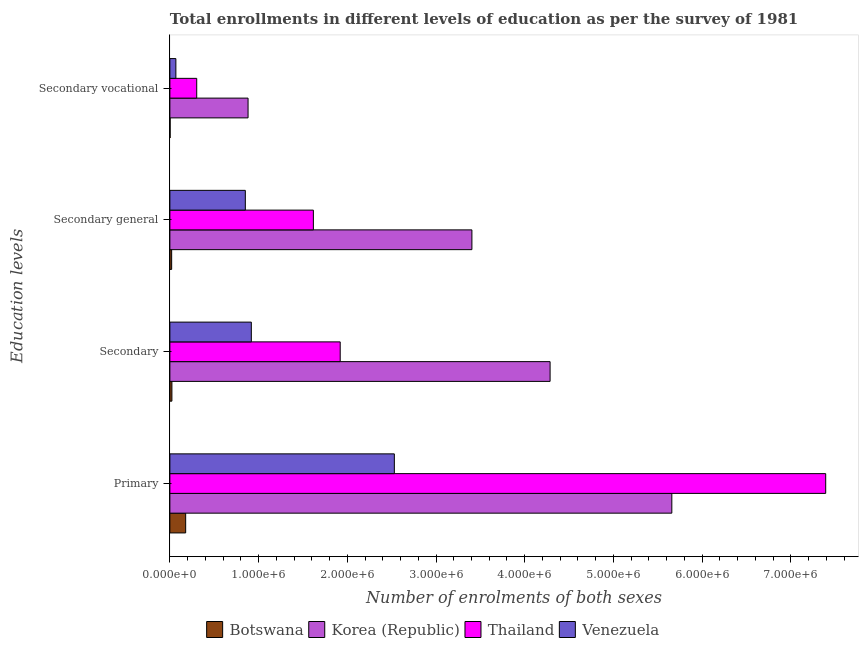How many different coloured bars are there?
Give a very brief answer. 4. Are the number of bars on each tick of the Y-axis equal?
Give a very brief answer. Yes. What is the label of the 3rd group of bars from the top?
Offer a very short reply. Secondary. What is the number of enrolments in primary education in Botswana?
Give a very brief answer. 1.78e+05. Across all countries, what is the maximum number of enrolments in secondary vocational education?
Provide a short and direct response. 8.81e+05. Across all countries, what is the minimum number of enrolments in secondary vocational education?
Ensure brevity in your answer.  2814. In which country was the number of enrolments in primary education maximum?
Provide a succinct answer. Thailand. In which country was the number of enrolments in secondary education minimum?
Provide a short and direct response. Botswana. What is the total number of enrolments in secondary vocational education in the graph?
Your response must be concise. 1.25e+06. What is the difference between the number of enrolments in secondary vocational education in Venezuela and that in Botswana?
Your response must be concise. 6.48e+04. What is the difference between the number of enrolments in secondary education in Korea (Republic) and the number of enrolments in secondary vocational education in Thailand?
Your answer should be compact. 3.98e+06. What is the average number of enrolments in primary education per country?
Give a very brief answer. 3.94e+06. What is the difference between the number of enrolments in secondary general education and number of enrolments in secondary vocational education in Venezuela?
Offer a terse response. 7.83e+05. In how many countries, is the number of enrolments in primary education greater than 4200000 ?
Provide a succinct answer. 2. What is the ratio of the number of enrolments in secondary vocational education in Botswana to that in Thailand?
Offer a very short reply. 0.01. Is the number of enrolments in primary education in Korea (Republic) less than that in Botswana?
Offer a terse response. No. What is the difference between the highest and the second highest number of enrolments in secondary education?
Give a very brief answer. 2.37e+06. What is the difference between the highest and the lowest number of enrolments in primary education?
Your response must be concise. 7.21e+06. In how many countries, is the number of enrolments in secondary education greater than the average number of enrolments in secondary education taken over all countries?
Ensure brevity in your answer.  2. Is it the case that in every country, the sum of the number of enrolments in primary education and number of enrolments in secondary vocational education is greater than the sum of number of enrolments in secondary general education and number of enrolments in secondary education?
Your answer should be compact. No. What does the 1st bar from the top in Primary represents?
Make the answer very short. Venezuela. Is it the case that in every country, the sum of the number of enrolments in primary education and number of enrolments in secondary education is greater than the number of enrolments in secondary general education?
Your answer should be compact. Yes. Are all the bars in the graph horizontal?
Keep it short and to the point. Yes. What is the difference between two consecutive major ticks on the X-axis?
Give a very brief answer. 1.00e+06. Are the values on the major ticks of X-axis written in scientific E-notation?
Your response must be concise. Yes. Does the graph contain any zero values?
Ensure brevity in your answer.  No. Where does the legend appear in the graph?
Make the answer very short. Bottom center. How many legend labels are there?
Provide a succinct answer. 4. What is the title of the graph?
Ensure brevity in your answer.  Total enrollments in different levels of education as per the survey of 1981. Does "Andorra" appear as one of the legend labels in the graph?
Offer a very short reply. No. What is the label or title of the X-axis?
Keep it short and to the point. Number of enrolments of both sexes. What is the label or title of the Y-axis?
Give a very brief answer. Education levels. What is the Number of enrolments of both sexes in Botswana in Primary?
Ensure brevity in your answer.  1.78e+05. What is the Number of enrolments of both sexes of Korea (Republic) in Primary?
Your response must be concise. 5.66e+06. What is the Number of enrolments of both sexes in Thailand in Primary?
Offer a terse response. 7.39e+06. What is the Number of enrolments of both sexes of Venezuela in Primary?
Your answer should be very brief. 2.53e+06. What is the Number of enrolments of both sexes in Botswana in Secondary?
Provide a short and direct response. 2.30e+04. What is the Number of enrolments of both sexes of Korea (Republic) in Secondary?
Offer a terse response. 4.29e+06. What is the Number of enrolments of both sexes in Thailand in Secondary?
Ensure brevity in your answer.  1.92e+06. What is the Number of enrolments of both sexes of Venezuela in Secondary?
Offer a terse response. 9.18e+05. What is the Number of enrolments of both sexes of Botswana in Secondary general?
Provide a succinct answer. 2.01e+04. What is the Number of enrolments of both sexes in Korea (Republic) in Secondary general?
Your answer should be compact. 3.40e+06. What is the Number of enrolments of both sexes of Thailand in Secondary general?
Keep it short and to the point. 1.62e+06. What is the Number of enrolments of both sexes of Venezuela in Secondary general?
Ensure brevity in your answer.  8.50e+05. What is the Number of enrolments of both sexes in Botswana in Secondary vocational?
Keep it short and to the point. 2814. What is the Number of enrolments of both sexes of Korea (Republic) in Secondary vocational?
Your answer should be very brief. 8.81e+05. What is the Number of enrolments of both sexes of Thailand in Secondary vocational?
Offer a terse response. 3.03e+05. What is the Number of enrolments of both sexes in Venezuela in Secondary vocational?
Offer a terse response. 6.76e+04. Across all Education levels, what is the maximum Number of enrolments of both sexes in Botswana?
Give a very brief answer. 1.78e+05. Across all Education levels, what is the maximum Number of enrolments of both sexes of Korea (Republic)?
Offer a very short reply. 5.66e+06. Across all Education levels, what is the maximum Number of enrolments of both sexes of Thailand?
Your answer should be very brief. 7.39e+06. Across all Education levels, what is the maximum Number of enrolments of both sexes of Venezuela?
Your response must be concise. 2.53e+06. Across all Education levels, what is the minimum Number of enrolments of both sexes in Botswana?
Provide a short and direct response. 2814. Across all Education levels, what is the minimum Number of enrolments of both sexes of Korea (Republic)?
Provide a short and direct response. 8.81e+05. Across all Education levels, what is the minimum Number of enrolments of both sexes of Thailand?
Offer a terse response. 3.03e+05. Across all Education levels, what is the minimum Number of enrolments of both sexes of Venezuela?
Provide a short and direct response. 6.76e+04. What is the total Number of enrolments of both sexes of Botswana in the graph?
Ensure brevity in your answer.  2.24e+05. What is the total Number of enrolments of both sexes of Korea (Republic) in the graph?
Keep it short and to the point. 1.42e+07. What is the total Number of enrolments of both sexes in Thailand in the graph?
Your response must be concise. 1.12e+07. What is the total Number of enrolments of both sexes in Venezuela in the graph?
Your answer should be compact. 4.37e+06. What is the difference between the Number of enrolments of both sexes of Botswana in Primary and that in Secondary?
Offer a very short reply. 1.55e+05. What is the difference between the Number of enrolments of both sexes in Korea (Republic) in Primary and that in Secondary?
Your response must be concise. 1.37e+06. What is the difference between the Number of enrolments of both sexes in Thailand in Primary and that in Secondary?
Give a very brief answer. 5.47e+06. What is the difference between the Number of enrolments of both sexes in Venezuela in Primary and that in Secondary?
Keep it short and to the point. 1.61e+06. What is the difference between the Number of enrolments of both sexes in Botswana in Primary and that in Secondary general?
Your response must be concise. 1.58e+05. What is the difference between the Number of enrolments of both sexes in Korea (Republic) in Primary and that in Secondary general?
Your answer should be very brief. 2.25e+06. What is the difference between the Number of enrolments of both sexes in Thailand in Primary and that in Secondary general?
Offer a terse response. 5.78e+06. What is the difference between the Number of enrolments of both sexes of Venezuela in Primary and that in Secondary general?
Keep it short and to the point. 1.68e+06. What is the difference between the Number of enrolments of both sexes in Botswana in Primary and that in Secondary vocational?
Offer a terse response. 1.75e+05. What is the difference between the Number of enrolments of both sexes in Korea (Republic) in Primary and that in Secondary vocational?
Provide a short and direct response. 4.78e+06. What is the difference between the Number of enrolments of both sexes of Thailand in Primary and that in Secondary vocational?
Your response must be concise. 7.09e+06. What is the difference between the Number of enrolments of both sexes in Venezuela in Primary and that in Secondary vocational?
Provide a short and direct response. 2.46e+06. What is the difference between the Number of enrolments of both sexes in Botswana in Secondary and that in Secondary general?
Your answer should be very brief. 2814. What is the difference between the Number of enrolments of both sexes of Korea (Republic) in Secondary and that in Secondary general?
Give a very brief answer. 8.81e+05. What is the difference between the Number of enrolments of both sexes in Thailand in Secondary and that in Secondary general?
Offer a very short reply. 3.03e+05. What is the difference between the Number of enrolments of both sexes in Venezuela in Secondary and that in Secondary general?
Your answer should be compact. 6.76e+04. What is the difference between the Number of enrolments of both sexes of Botswana in Secondary and that in Secondary vocational?
Make the answer very short. 2.01e+04. What is the difference between the Number of enrolments of both sexes of Korea (Republic) in Secondary and that in Secondary vocational?
Offer a terse response. 3.40e+06. What is the difference between the Number of enrolments of both sexes of Thailand in Secondary and that in Secondary vocational?
Give a very brief answer. 1.62e+06. What is the difference between the Number of enrolments of both sexes of Venezuela in Secondary and that in Secondary vocational?
Ensure brevity in your answer.  8.50e+05. What is the difference between the Number of enrolments of both sexes of Botswana in Secondary general and that in Secondary vocational?
Your response must be concise. 1.73e+04. What is the difference between the Number of enrolments of both sexes in Korea (Republic) in Secondary general and that in Secondary vocational?
Keep it short and to the point. 2.52e+06. What is the difference between the Number of enrolments of both sexes in Thailand in Secondary general and that in Secondary vocational?
Provide a succinct answer. 1.31e+06. What is the difference between the Number of enrolments of both sexes of Venezuela in Secondary general and that in Secondary vocational?
Make the answer very short. 7.83e+05. What is the difference between the Number of enrolments of both sexes of Botswana in Primary and the Number of enrolments of both sexes of Korea (Republic) in Secondary?
Your response must be concise. -4.11e+06. What is the difference between the Number of enrolments of both sexes in Botswana in Primary and the Number of enrolments of both sexes in Thailand in Secondary?
Give a very brief answer. -1.74e+06. What is the difference between the Number of enrolments of both sexes in Botswana in Primary and the Number of enrolments of both sexes in Venezuela in Secondary?
Your answer should be very brief. -7.40e+05. What is the difference between the Number of enrolments of both sexes of Korea (Republic) in Primary and the Number of enrolments of both sexes of Thailand in Secondary?
Your answer should be very brief. 3.74e+06. What is the difference between the Number of enrolments of both sexes of Korea (Republic) in Primary and the Number of enrolments of both sexes of Venezuela in Secondary?
Make the answer very short. 4.74e+06. What is the difference between the Number of enrolments of both sexes in Thailand in Primary and the Number of enrolments of both sexes in Venezuela in Secondary?
Your answer should be compact. 6.47e+06. What is the difference between the Number of enrolments of both sexes in Botswana in Primary and the Number of enrolments of both sexes in Korea (Republic) in Secondary general?
Offer a very short reply. -3.23e+06. What is the difference between the Number of enrolments of both sexes of Botswana in Primary and the Number of enrolments of both sexes of Thailand in Secondary general?
Give a very brief answer. -1.44e+06. What is the difference between the Number of enrolments of both sexes in Botswana in Primary and the Number of enrolments of both sexes in Venezuela in Secondary general?
Make the answer very short. -6.72e+05. What is the difference between the Number of enrolments of both sexes of Korea (Republic) in Primary and the Number of enrolments of both sexes of Thailand in Secondary general?
Keep it short and to the point. 4.04e+06. What is the difference between the Number of enrolments of both sexes in Korea (Republic) in Primary and the Number of enrolments of both sexes in Venezuela in Secondary general?
Your answer should be very brief. 4.81e+06. What is the difference between the Number of enrolments of both sexes in Thailand in Primary and the Number of enrolments of both sexes in Venezuela in Secondary general?
Keep it short and to the point. 6.54e+06. What is the difference between the Number of enrolments of both sexes of Botswana in Primary and the Number of enrolments of both sexes of Korea (Republic) in Secondary vocational?
Provide a short and direct response. -7.03e+05. What is the difference between the Number of enrolments of both sexes of Botswana in Primary and the Number of enrolments of both sexes of Thailand in Secondary vocational?
Make the answer very short. -1.24e+05. What is the difference between the Number of enrolments of both sexes in Botswana in Primary and the Number of enrolments of both sexes in Venezuela in Secondary vocational?
Provide a short and direct response. 1.10e+05. What is the difference between the Number of enrolments of both sexes of Korea (Republic) in Primary and the Number of enrolments of both sexes of Thailand in Secondary vocational?
Provide a succinct answer. 5.36e+06. What is the difference between the Number of enrolments of both sexes of Korea (Republic) in Primary and the Number of enrolments of both sexes of Venezuela in Secondary vocational?
Offer a terse response. 5.59e+06. What is the difference between the Number of enrolments of both sexes of Thailand in Primary and the Number of enrolments of both sexes of Venezuela in Secondary vocational?
Provide a succinct answer. 7.32e+06. What is the difference between the Number of enrolments of both sexes in Botswana in Secondary and the Number of enrolments of both sexes in Korea (Republic) in Secondary general?
Keep it short and to the point. -3.38e+06. What is the difference between the Number of enrolments of both sexes in Botswana in Secondary and the Number of enrolments of both sexes in Thailand in Secondary general?
Provide a short and direct response. -1.59e+06. What is the difference between the Number of enrolments of both sexes in Botswana in Secondary and the Number of enrolments of both sexes in Venezuela in Secondary general?
Your answer should be compact. -8.28e+05. What is the difference between the Number of enrolments of both sexes of Korea (Republic) in Secondary and the Number of enrolments of both sexes of Thailand in Secondary general?
Offer a terse response. 2.67e+06. What is the difference between the Number of enrolments of both sexes of Korea (Republic) in Secondary and the Number of enrolments of both sexes of Venezuela in Secondary general?
Your answer should be compact. 3.44e+06. What is the difference between the Number of enrolments of both sexes of Thailand in Secondary and the Number of enrolments of both sexes of Venezuela in Secondary general?
Offer a very short reply. 1.07e+06. What is the difference between the Number of enrolments of both sexes in Botswana in Secondary and the Number of enrolments of both sexes in Korea (Republic) in Secondary vocational?
Provide a succinct answer. -8.58e+05. What is the difference between the Number of enrolments of both sexes in Botswana in Secondary and the Number of enrolments of both sexes in Thailand in Secondary vocational?
Provide a succinct answer. -2.80e+05. What is the difference between the Number of enrolments of both sexes of Botswana in Secondary and the Number of enrolments of both sexes of Venezuela in Secondary vocational?
Offer a terse response. -4.47e+04. What is the difference between the Number of enrolments of both sexes in Korea (Republic) in Secondary and the Number of enrolments of both sexes in Thailand in Secondary vocational?
Offer a very short reply. 3.98e+06. What is the difference between the Number of enrolments of both sexes of Korea (Republic) in Secondary and the Number of enrolments of both sexes of Venezuela in Secondary vocational?
Make the answer very short. 4.22e+06. What is the difference between the Number of enrolments of both sexes of Thailand in Secondary and the Number of enrolments of both sexes of Venezuela in Secondary vocational?
Your answer should be very brief. 1.85e+06. What is the difference between the Number of enrolments of both sexes of Botswana in Secondary general and the Number of enrolments of both sexes of Korea (Republic) in Secondary vocational?
Provide a short and direct response. -8.61e+05. What is the difference between the Number of enrolments of both sexes of Botswana in Secondary general and the Number of enrolments of both sexes of Thailand in Secondary vocational?
Provide a short and direct response. -2.82e+05. What is the difference between the Number of enrolments of both sexes in Botswana in Secondary general and the Number of enrolments of both sexes in Venezuela in Secondary vocational?
Ensure brevity in your answer.  -4.75e+04. What is the difference between the Number of enrolments of both sexes in Korea (Republic) in Secondary general and the Number of enrolments of both sexes in Thailand in Secondary vocational?
Your answer should be compact. 3.10e+06. What is the difference between the Number of enrolments of both sexes of Korea (Republic) in Secondary general and the Number of enrolments of both sexes of Venezuela in Secondary vocational?
Provide a succinct answer. 3.34e+06. What is the difference between the Number of enrolments of both sexes in Thailand in Secondary general and the Number of enrolments of both sexes in Venezuela in Secondary vocational?
Provide a succinct answer. 1.55e+06. What is the average Number of enrolments of both sexes in Botswana per Education levels?
Ensure brevity in your answer.  5.60e+04. What is the average Number of enrolments of both sexes of Korea (Republic) per Education levels?
Provide a succinct answer. 3.56e+06. What is the average Number of enrolments of both sexes in Thailand per Education levels?
Provide a short and direct response. 2.81e+06. What is the average Number of enrolments of both sexes of Venezuela per Education levels?
Your answer should be very brief. 1.09e+06. What is the difference between the Number of enrolments of both sexes of Botswana and Number of enrolments of both sexes of Korea (Republic) in Primary?
Your response must be concise. -5.48e+06. What is the difference between the Number of enrolments of both sexes in Botswana and Number of enrolments of both sexes in Thailand in Primary?
Give a very brief answer. -7.21e+06. What is the difference between the Number of enrolments of both sexes of Botswana and Number of enrolments of both sexes of Venezuela in Primary?
Ensure brevity in your answer.  -2.35e+06. What is the difference between the Number of enrolments of both sexes in Korea (Republic) and Number of enrolments of both sexes in Thailand in Primary?
Offer a terse response. -1.73e+06. What is the difference between the Number of enrolments of both sexes in Korea (Republic) and Number of enrolments of both sexes in Venezuela in Primary?
Keep it short and to the point. 3.13e+06. What is the difference between the Number of enrolments of both sexes of Thailand and Number of enrolments of both sexes of Venezuela in Primary?
Your answer should be very brief. 4.86e+06. What is the difference between the Number of enrolments of both sexes in Botswana and Number of enrolments of both sexes in Korea (Republic) in Secondary?
Ensure brevity in your answer.  -4.26e+06. What is the difference between the Number of enrolments of both sexes in Botswana and Number of enrolments of both sexes in Thailand in Secondary?
Your answer should be very brief. -1.90e+06. What is the difference between the Number of enrolments of both sexes in Botswana and Number of enrolments of both sexes in Venezuela in Secondary?
Your answer should be very brief. -8.95e+05. What is the difference between the Number of enrolments of both sexes of Korea (Republic) and Number of enrolments of both sexes of Thailand in Secondary?
Ensure brevity in your answer.  2.37e+06. What is the difference between the Number of enrolments of both sexes in Korea (Republic) and Number of enrolments of both sexes in Venezuela in Secondary?
Your response must be concise. 3.37e+06. What is the difference between the Number of enrolments of both sexes in Thailand and Number of enrolments of both sexes in Venezuela in Secondary?
Offer a terse response. 1.00e+06. What is the difference between the Number of enrolments of both sexes of Botswana and Number of enrolments of both sexes of Korea (Republic) in Secondary general?
Your answer should be compact. -3.38e+06. What is the difference between the Number of enrolments of both sexes of Botswana and Number of enrolments of both sexes of Thailand in Secondary general?
Keep it short and to the point. -1.60e+06. What is the difference between the Number of enrolments of both sexes in Botswana and Number of enrolments of both sexes in Venezuela in Secondary general?
Your answer should be compact. -8.30e+05. What is the difference between the Number of enrolments of both sexes of Korea (Republic) and Number of enrolments of both sexes of Thailand in Secondary general?
Offer a terse response. 1.79e+06. What is the difference between the Number of enrolments of both sexes of Korea (Republic) and Number of enrolments of both sexes of Venezuela in Secondary general?
Your response must be concise. 2.55e+06. What is the difference between the Number of enrolments of both sexes of Thailand and Number of enrolments of both sexes of Venezuela in Secondary general?
Provide a succinct answer. 7.67e+05. What is the difference between the Number of enrolments of both sexes of Botswana and Number of enrolments of both sexes of Korea (Republic) in Secondary vocational?
Your answer should be very brief. -8.78e+05. What is the difference between the Number of enrolments of both sexes in Botswana and Number of enrolments of both sexes in Thailand in Secondary vocational?
Offer a very short reply. -3.00e+05. What is the difference between the Number of enrolments of both sexes in Botswana and Number of enrolments of both sexes in Venezuela in Secondary vocational?
Provide a succinct answer. -6.48e+04. What is the difference between the Number of enrolments of both sexes in Korea (Republic) and Number of enrolments of both sexes in Thailand in Secondary vocational?
Give a very brief answer. 5.79e+05. What is the difference between the Number of enrolments of both sexes of Korea (Republic) and Number of enrolments of both sexes of Venezuela in Secondary vocational?
Make the answer very short. 8.14e+05. What is the difference between the Number of enrolments of both sexes of Thailand and Number of enrolments of both sexes of Venezuela in Secondary vocational?
Offer a terse response. 2.35e+05. What is the ratio of the Number of enrolments of both sexes in Botswana in Primary to that in Secondary?
Provide a succinct answer. 7.76. What is the ratio of the Number of enrolments of both sexes in Korea (Republic) in Primary to that in Secondary?
Offer a terse response. 1.32. What is the ratio of the Number of enrolments of both sexes of Thailand in Primary to that in Secondary?
Your answer should be very brief. 3.85. What is the ratio of the Number of enrolments of both sexes in Venezuela in Primary to that in Secondary?
Offer a terse response. 2.76. What is the ratio of the Number of enrolments of both sexes in Botswana in Primary to that in Secondary general?
Your answer should be compact. 8.84. What is the ratio of the Number of enrolments of both sexes of Korea (Republic) in Primary to that in Secondary general?
Your answer should be very brief. 1.66. What is the ratio of the Number of enrolments of both sexes of Thailand in Primary to that in Secondary general?
Offer a terse response. 4.57. What is the ratio of the Number of enrolments of both sexes of Venezuela in Primary to that in Secondary general?
Your answer should be compact. 2.98. What is the ratio of the Number of enrolments of both sexes of Botswana in Primary to that in Secondary vocational?
Offer a very short reply. 63.29. What is the ratio of the Number of enrolments of both sexes of Korea (Republic) in Primary to that in Secondary vocational?
Give a very brief answer. 6.42. What is the ratio of the Number of enrolments of both sexes in Thailand in Primary to that in Secondary vocational?
Your answer should be very brief. 24.44. What is the ratio of the Number of enrolments of both sexes of Venezuela in Primary to that in Secondary vocational?
Keep it short and to the point. 37.41. What is the ratio of the Number of enrolments of both sexes in Botswana in Secondary to that in Secondary general?
Ensure brevity in your answer.  1.14. What is the ratio of the Number of enrolments of both sexes in Korea (Republic) in Secondary to that in Secondary general?
Provide a short and direct response. 1.26. What is the ratio of the Number of enrolments of both sexes in Thailand in Secondary to that in Secondary general?
Ensure brevity in your answer.  1.19. What is the ratio of the Number of enrolments of both sexes in Venezuela in Secondary to that in Secondary general?
Your answer should be very brief. 1.08. What is the ratio of the Number of enrolments of both sexes of Botswana in Secondary to that in Secondary vocational?
Ensure brevity in your answer.  8.16. What is the ratio of the Number of enrolments of both sexes in Korea (Republic) in Secondary to that in Secondary vocational?
Your answer should be very brief. 4.86. What is the ratio of the Number of enrolments of both sexes of Thailand in Secondary to that in Secondary vocational?
Make the answer very short. 6.35. What is the ratio of the Number of enrolments of both sexes of Venezuela in Secondary to that in Secondary vocational?
Provide a succinct answer. 13.57. What is the ratio of the Number of enrolments of both sexes in Botswana in Secondary general to that in Secondary vocational?
Give a very brief answer. 7.16. What is the ratio of the Number of enrolments of both sexes in Korea (Republic) in Secondary general to that in Secondary vocational?
Ensure brevity in your answer.  3.86. What is the ratio of the Number of enrolments of both sexes of Thailand in Secondary general to that in Secondary vocational?
Offer a terse response. 5.35. What is the ratio of the Number of enrolments of both sexes in Venezuela in Secondary general to that in Secondary vocational?
Your response must be concise. 12.57. What is the difference between the highest and the second highest Number of enrolments of both sexes in Botswana?
Your answer should be compact. 1.55e+05. What is the difference between the highest and the second highest Number of enrolments of both sexes of Korea (Republic)?
Your answer should be very brief. 1.37e+06. What is the difference between the highest and the second highest Number of enrolments of both sexes of Thailand?
Your response must be concise. 5.47e+06. What is the difference between the highest and the second highest Number of enrolments of both sexes of Venezuela?
Your response must be concise. 1.61e+06. What is the difference between the highest and the lowest Number of enrolments of both sexes of Botswana?
Your answer should be compact. 1.75e+05. What is the difference between the highest and the lowest Number of enrolments of both sexes of Korea (Republic)?
Your answer should be very brief. 4.78e+06. What is the difference between the highest and the lowest Number of enrolments of both sexes in Thailand?
Provide a succinct answer. 7.09e+06. What is the difference between the highest and the lowest Number of enrolments of both sexes of Venezuela?
Give a very brief answer. 2.46e+06. 